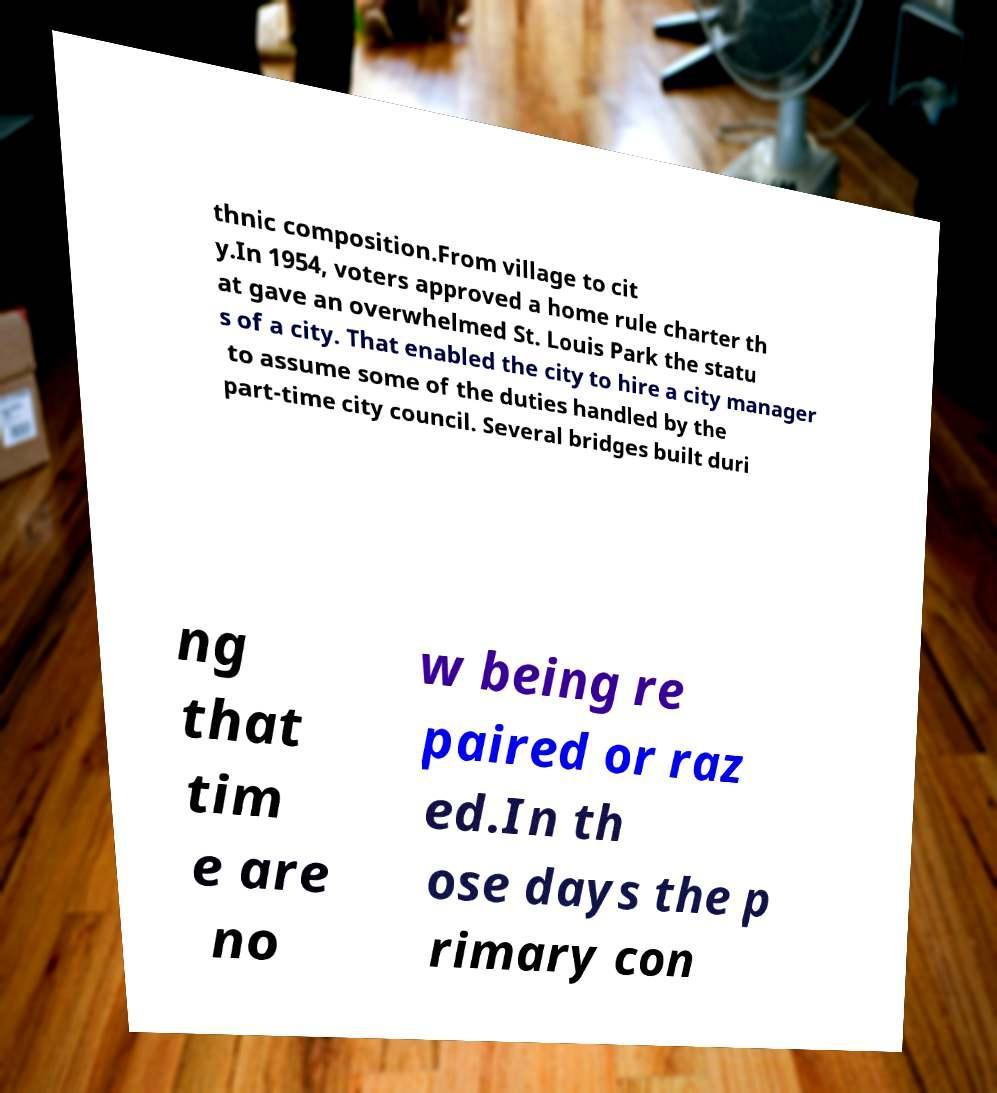Could you extract and type out the text from this image? thnic composition.From village to cit y.In 1954, voters approved a home rule charter th at gave an overwhelmed St. Louis Park the statu s of a city. That enabled the city to hire a city manager to assume some of the duties handled by the part-time city council. Several bridges built duri ng that tim e are no w being re paired or raz ed.In th ose days the p rimary con 